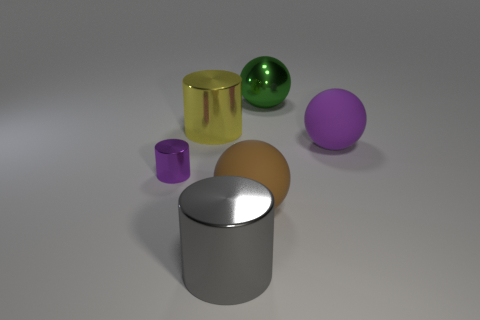Add 4 tiny cylinders. How many objects exist? 10 Add 5 big purple matte things. How many big purple matte things are left? 6 Add 1 green shiny objects. How many green shiny objects exist? 2 Subtract 1 purple cylinders. How many objects are left? 5 Subtract all big yellow metallic things. Subtract all large purple spheres. How many objects are left? 4 